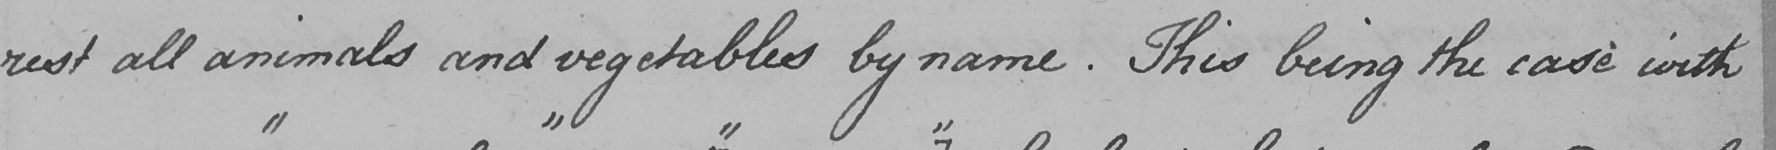Can you tell me what this handwritten text says? rest all animals and vegetables by name . This being the case with 